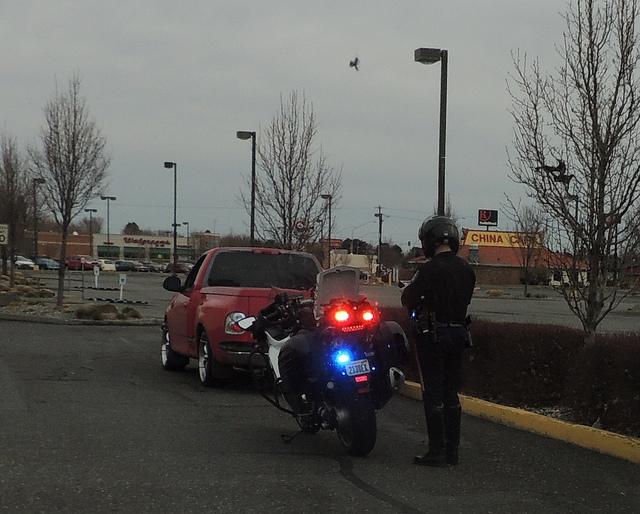Why is the truck getting pulled over?
Short answer required. Speeding. What color is the truck that was pulled over?
Short answer required. Red. Is there a large crowd?
Write a very short answer. No. What makes the road conditions in this picture dangerous?
Quick response, please. No. What type of business is in the background?
Be succinct. Walgreens. 